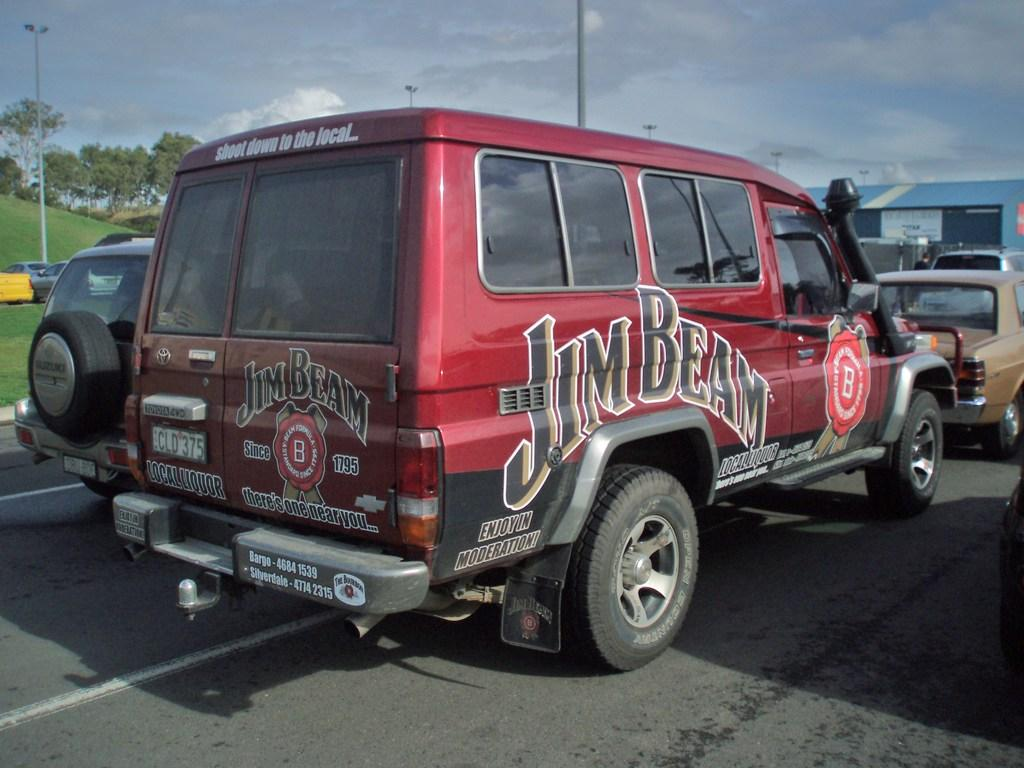What can be seen on the road in the image? There are vehicles on the road in the image. What type of structure is present in the image? There is a shed in the image. What are the tall, thin objects in the image? There are poles in the image. What type of vegetation is visible in the background of the image? There are trees in the background of the image. What type of ground cover is visible in the background of the image? There is grass in the background of the image. What part of the natural environment is visible in the background of the image? The sky is visible in the background of the image. What type of hole can be seen in the sky in the image? There is no hole present in the sky in the image. What type of voice can be heard coming from the vehicles in the image? There is no indication of sound or voice in the image, as it is a still photograph. 